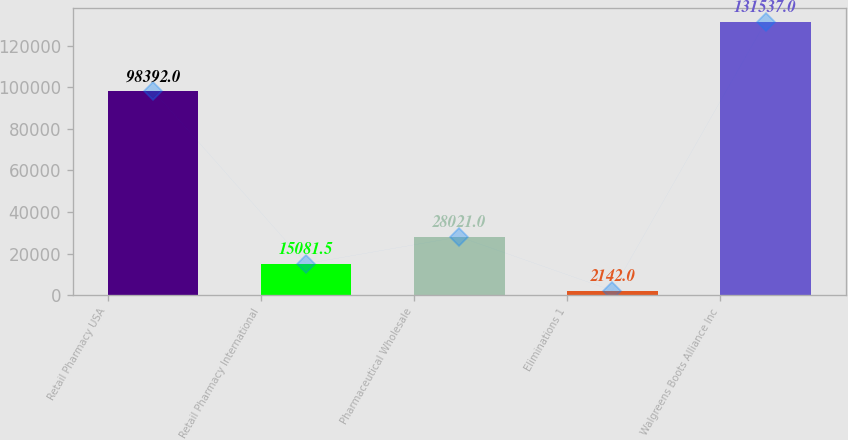Convert chart to OTSL. <chart><loc_0><loc_0><loc_500><loc_500><bar_chart><fcel>Retail Pharmacy USA<fcel>Retail Pharmacy International<fcel>Pharmaceutical Wholesale<fcel>Eliminations 1<fcel>Walgreens Boots Alliance Inc<nl><fcel>98392<fcel>15081.5<fcel>28021<fcel>2142<fcel>131537<nl></chart> 